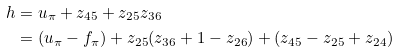<formula> <loc_0><loc_0><loc_500><loc_500>h & = u _ { \pi } + z _ { 4 5 } + z _ { 2 5 } z _ { 3 6 } \\ & = ( u _ { \pi } - f _ { \pi } ) + z _ { 2 5 } ( z _ { 3 6 } + 1 - z _ { 2 6 } ) + ( z _ { 4 5 } - z _ { 2 5 } + z _ { 2 4 } )</formula> 